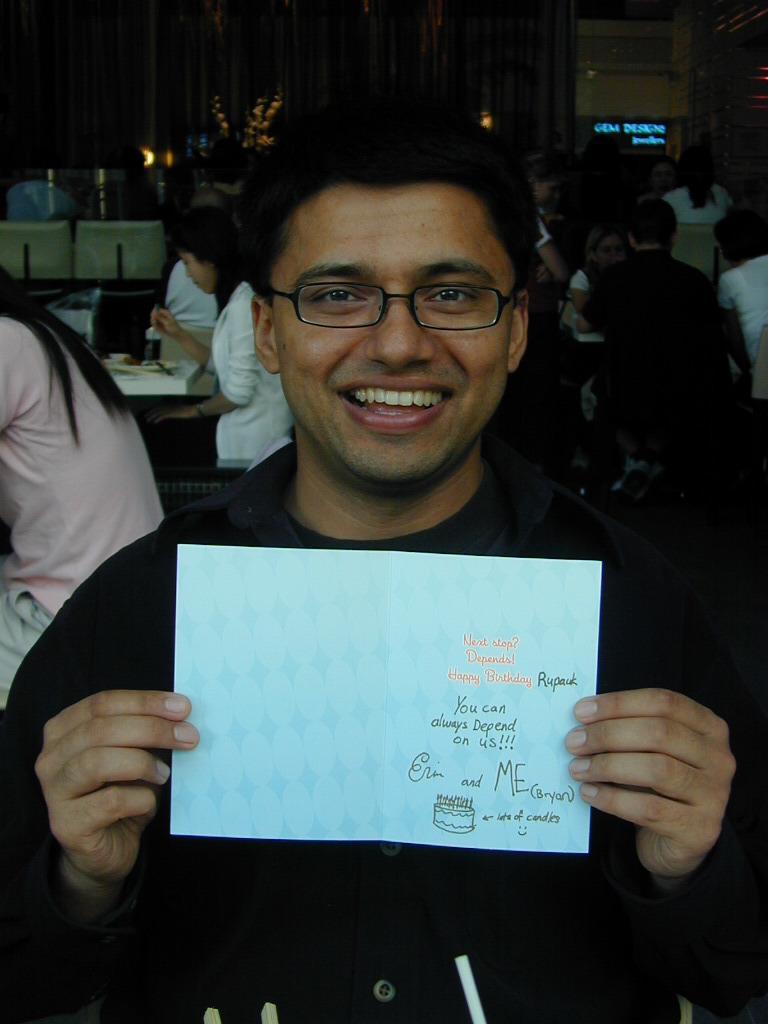In one or two sentences, can you explain what this image depicts? In this picture we can see a person holding a card. There are few people and a curtain in the background. We can see a few lights. 